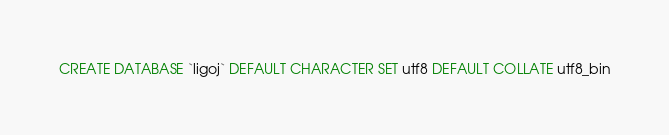<code> <loc_0><loc_0><loc_500><loc_500><_SQL_>CREATE DATABASE `ligoj` DEFAULT CHARACTER SET utf8 DEFAULT COLLATE utf8_bin</code> 